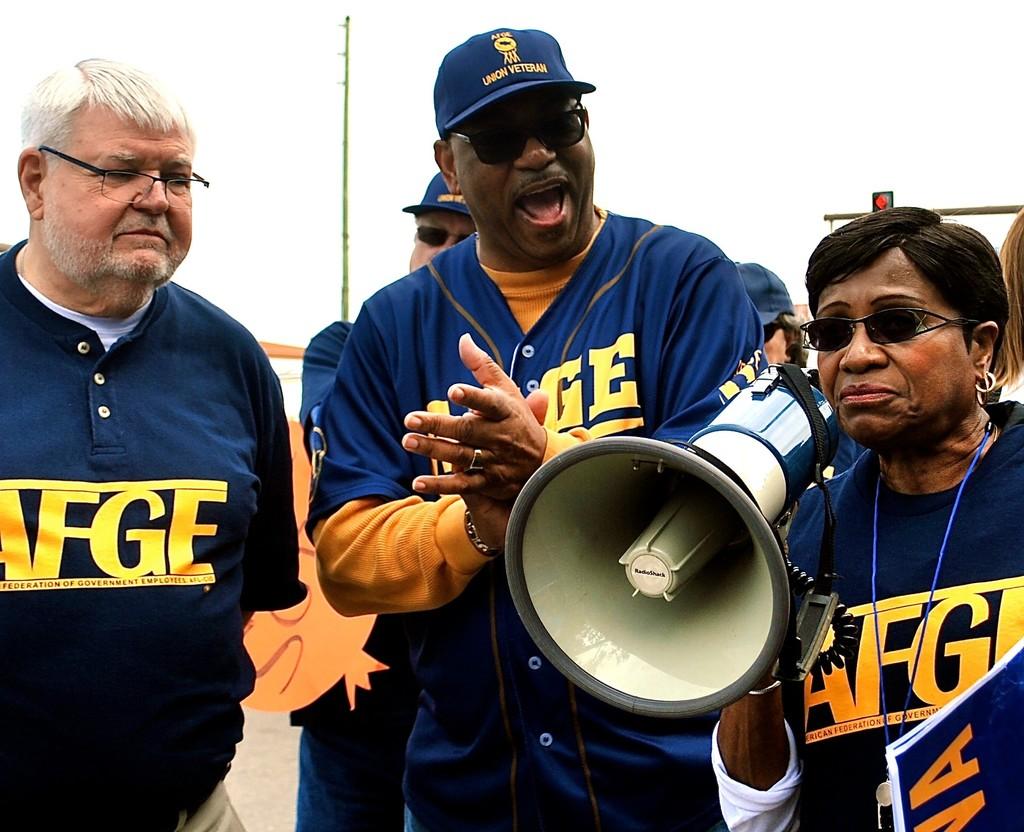What are the last two letters on the shirt?
Provide a short and direct response. Ge. What is written on the hat?
Offer a terse response. Union veteran. 